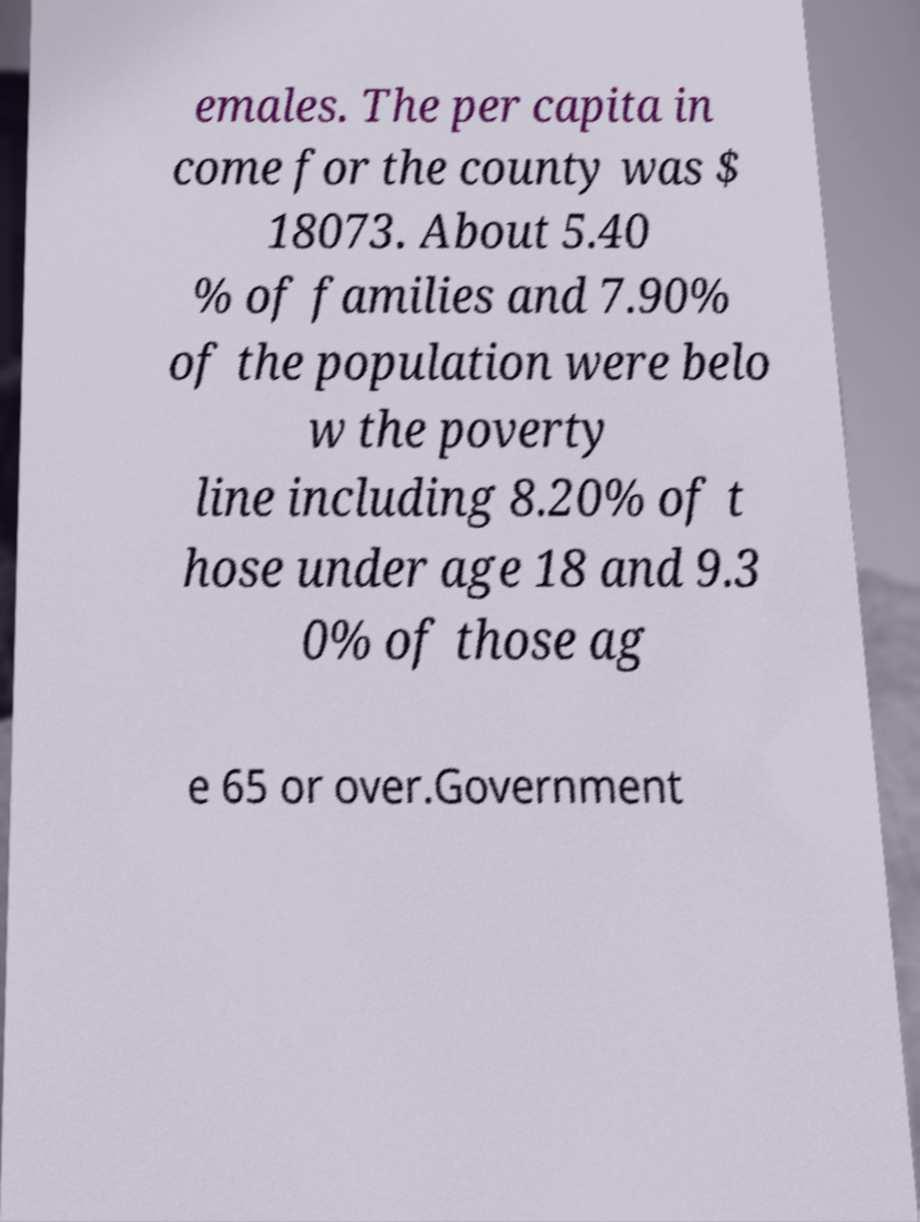Can you read and provide the text displayed in the image?This photo seems to have some interesting text. Can you extract and type it out for me? emales. The per capita in come for the county was $ 18073. About 5.40 % of families and 7.90% of the population were belo w the poverty line including 8.20% of t hose under age 18 and 9.3 0% of those ag e 65 or over.Government 